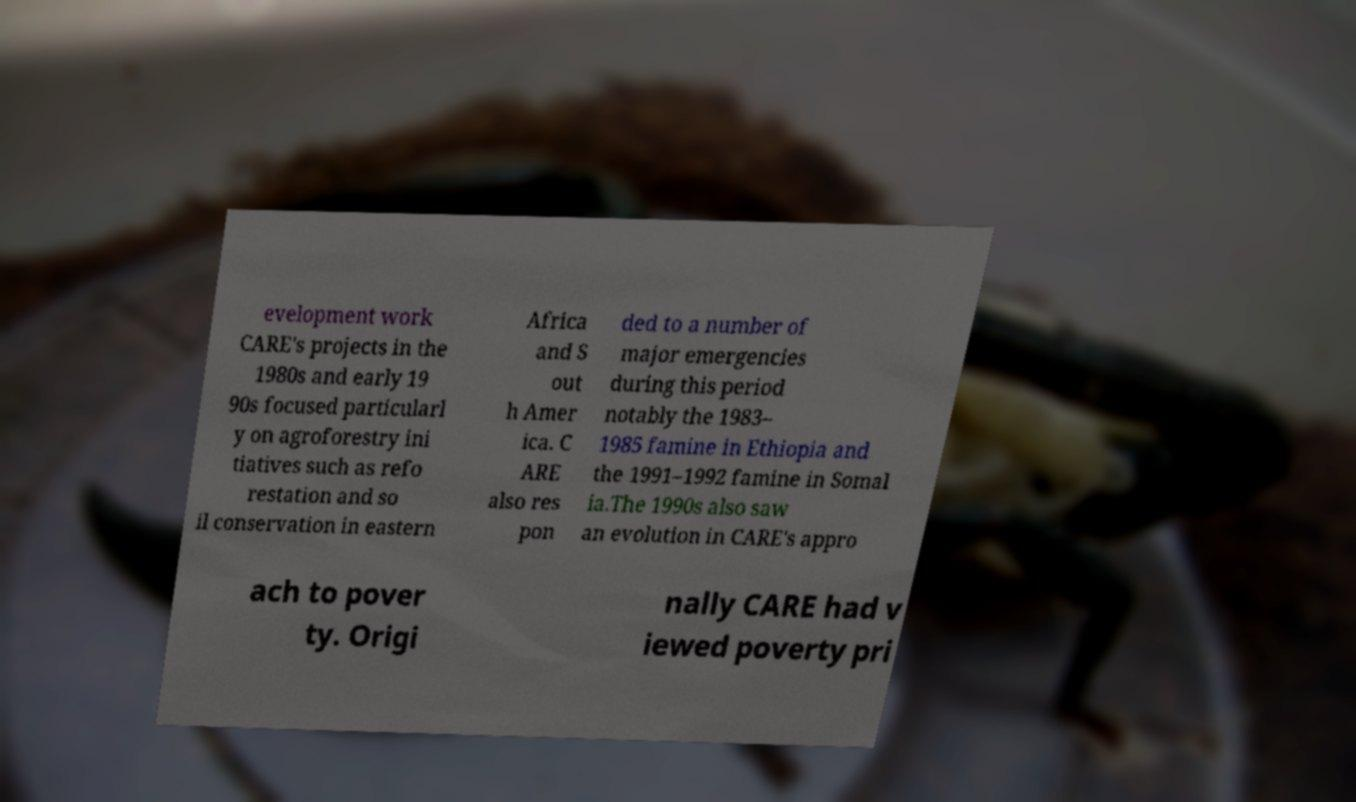What messages or text are displayed in this image? I need them in a readable, typed format. evelopment work CARE's projects in the 1980s and early 19 90s focused particularl y on agroforestry ini tiatives such as refo restation and so il conservation in eastern Africa and S out h Amer ica. C ARE also res pon ded to a number of major emergencies during this period notably the 1983– 1985 famine in Ethiopia and the 1991–1992 famine in Somal ia.The 1990s also saw an evolution in CARE's appro ach to pover ty. Origi nally CARE had v iewed poverty pri 